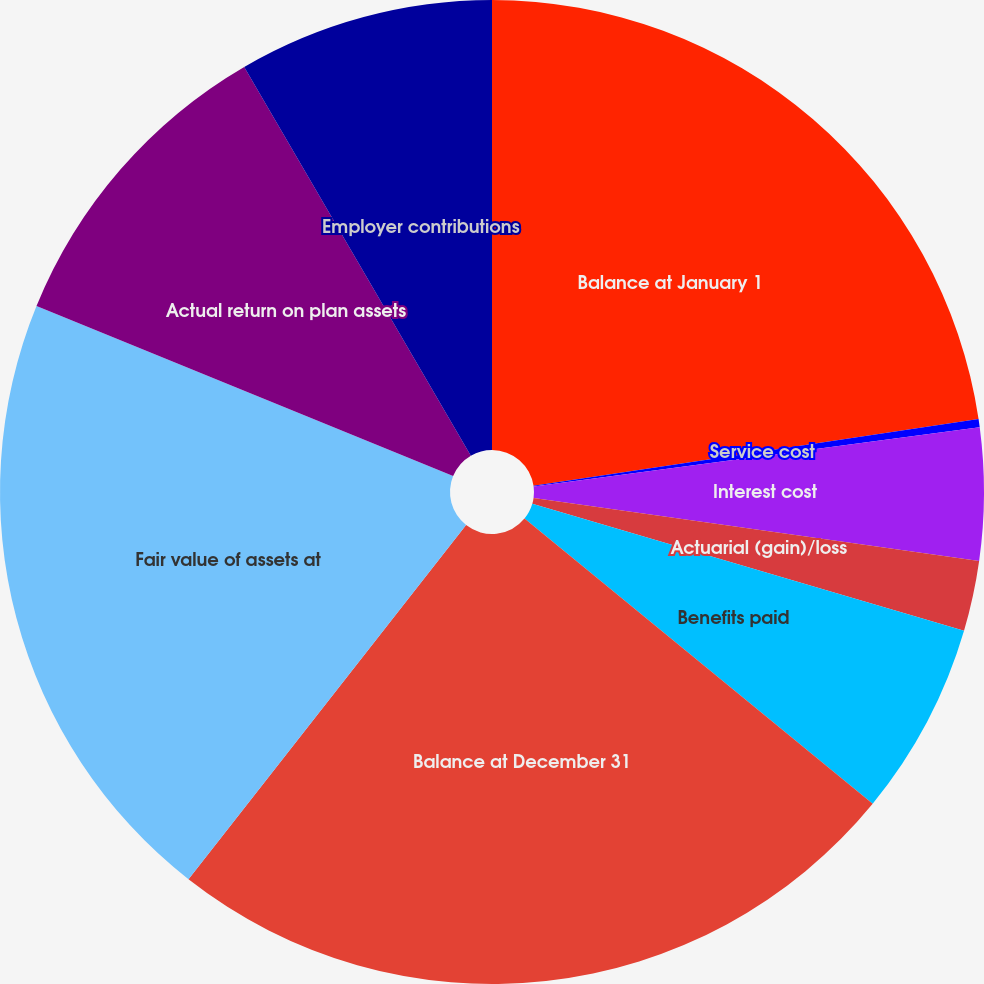<chart> <loc_0><loc_0><loc_500><loc_500><pie_chart><fcel>Balance at January 1<fcel>Service cost<fcel>Interest cost<fcel>Actuarial (gain)/loss<fcel>Benefits paid<fcel>Balance at December 31<fcel>Fair value of assets at<fcel>Actual return on plan assets<fcel>Employer contributions<nl><fcel>22.63%<fcel>0.27%<fcel>4.34%<fcel>2.31%<fcel>6.37%<fcel>24.66%<fcel>20.59%<fcel>10.43%<fcel>8.4%<nl></chart> 